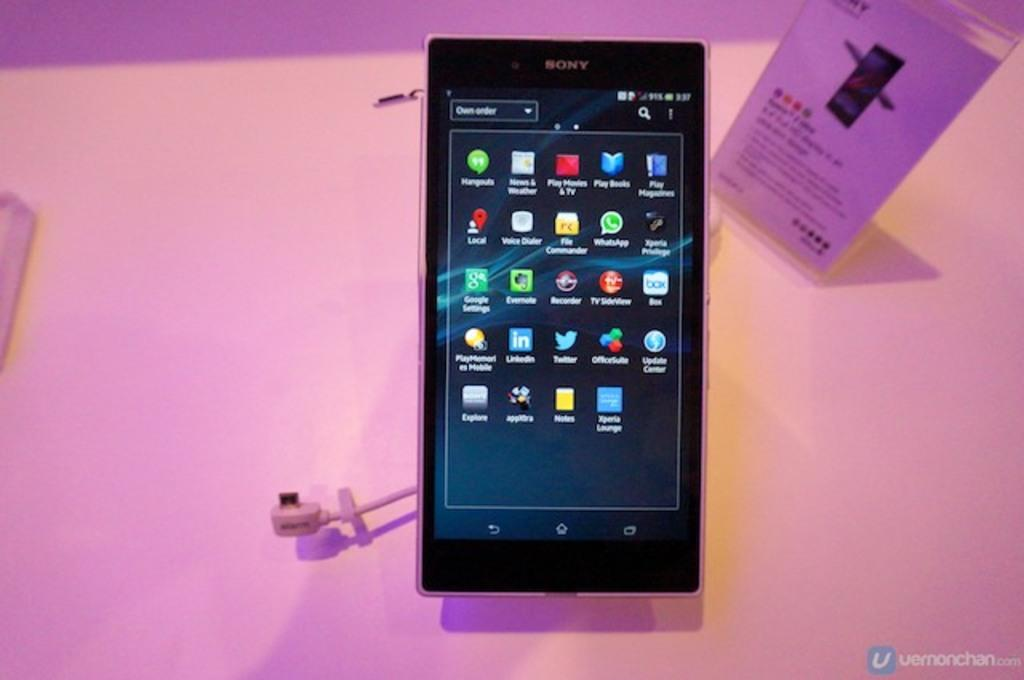<image>
Share a concise interpretation of the image provided. A cell phone displaying different apps including Play Books and Play Movies & TV. 